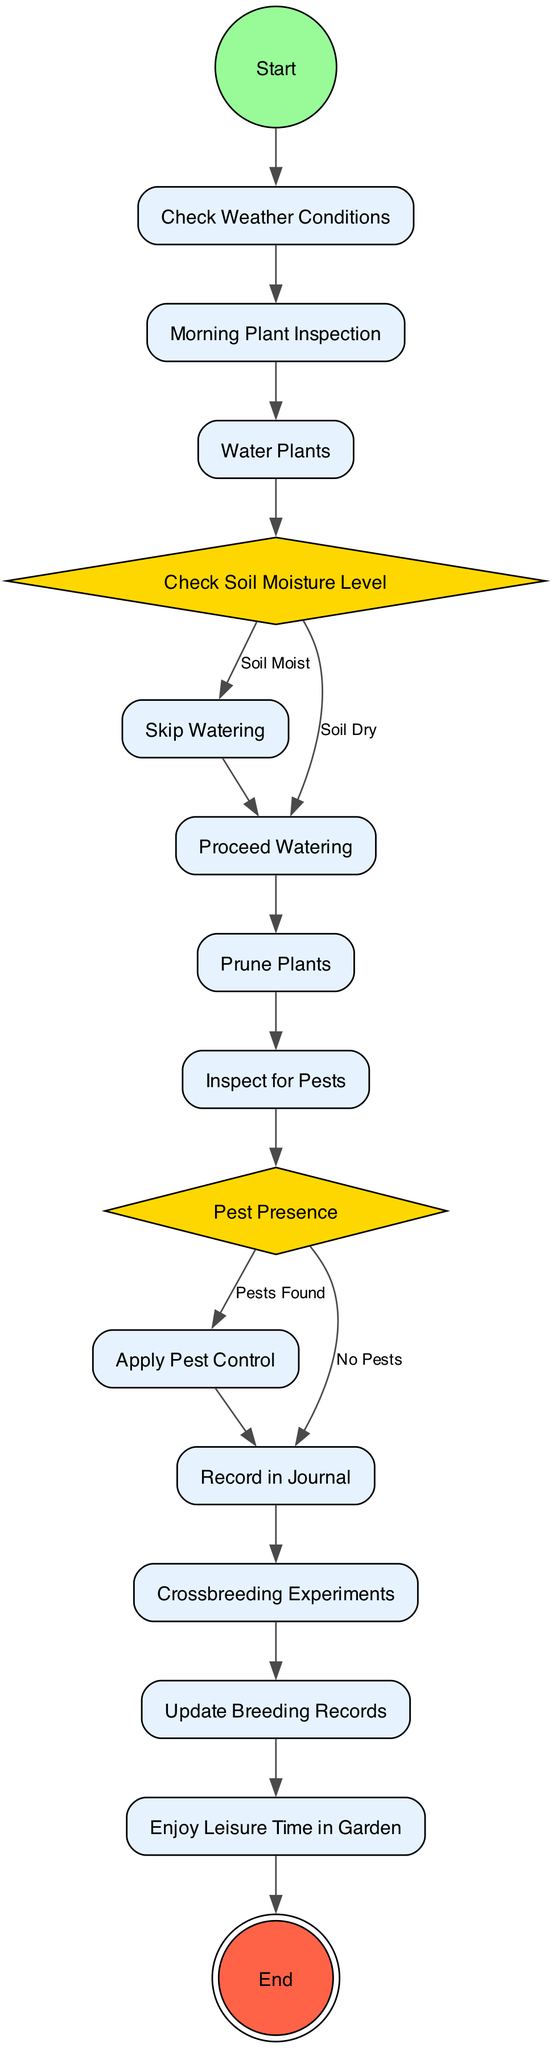What is the first action in the diagram? The diagram starts with the initial node, which leads to the first action node named "Check Weather Conditions." Therefore, the first action in the process is "Check Weather Conditions."
Answer: Check Weather Conditions How many decision nodes are in the diagram? The diagram contains two decision nodes: "Check Soil Moisture Level" and "Pest Presence." Thus, the total count is two decision nodes.
Answer: 2 What action follows "Skip Watering"? After "Skip Watering," the next action in the flow of the diagram is "Prune Plants." This is the subsequent action that follows after no watering is required.
Answer: Prune Plants What occurs if pests are found during plant inspections? If pests are found during the "Inspect for Pests" action, the flow leads to the action "Apply Pest Control." This indicates direct action taken when pests are detected.
Answer: Apply Pest Control Which action comes after "Crossbreeding Experiments"? Following the action "Crossbreeding Experiments" in the sequence of activities is the action "Update Breeding Records." This progression implies that updating the records is a subsequent step after experiments.
Answer: Update Breeding Records Is there a final action in the diagram? Yes, the final action in the diagram is represented by the "End" node, indicating that the routine concludes after all preceding activities.
Answer: End What is the total number of actions in the diagram? The diagram lists a total of 11 actions, which includes every action taken during the daily gardening routine as outlined in the flow.
Answer: 11 What is the main purpose of the "Record in Journal" action? The "Record in Journal" action is carried out when there are "No Pests" detected, signifying documentation of observations after inspections. Therefore, it serves the purpose of tracking information in the gardening process.
Answer: Record in Journal What comes after "Water Plants" if the soil is dry? If the soil is dry during the "Water Plants" action, the next step is "Proceed Watering," indicating that watering will take place. This is based on the condition of the soil being dry.
Answer: Proceed Watering 